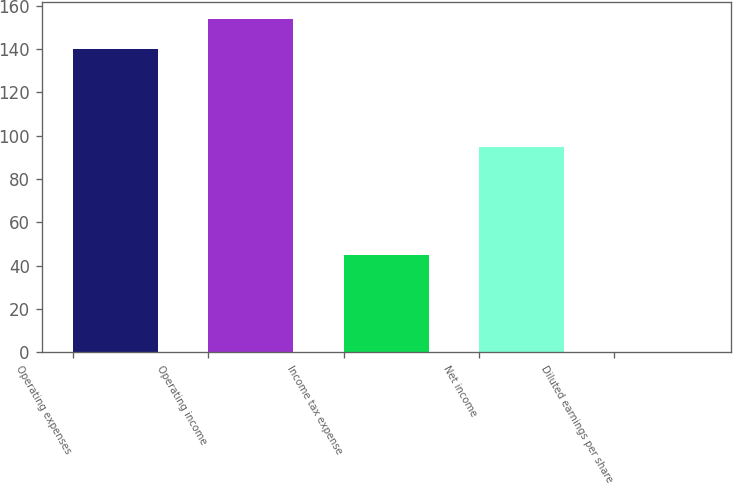<chart> <loc_0><loc_0><loc_500><loc_500><bar_chart><fcel>Operating expenses<fcel>Operating income<fcel>Income tax expense<fcel>Net income<fcel>Diluted earnings per share<nl><fcel>140<fcel>153.99<fcel>45<fcel>95<fcel>0.08<nl></chart> 